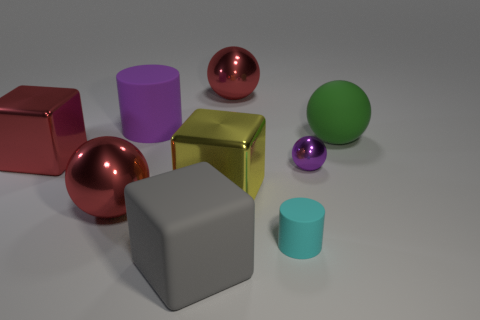Subtract all big yellow metallic blocks. How many blocks are left? 2 Subtract all blue cubes. How many red balls are left? 2 Subtract all yellow blocks. How many blocks are left? 2 Subtract all balls. How many objects are left? 5 Subtract 2 spheres. How many spheres are left? 2 Add 1 cyan shiny balls. How many objects exist? 10 Subtract all tiny brown matte cubes. Subtract all tiny cyan rubber objects. How many objects are left? 8 Add 4 large gray blocks. How many large gray blocks are left? 5 Add 2 yellow rubber spheres. How many yellow rubber spheres exist? 2 Subtract 0 blue balls. How many objects are left? 9 